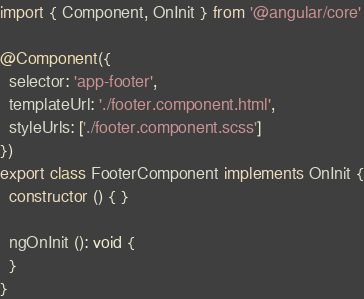Convert code to text. <code><loc_0><loc_0><loc_500><loc_500><_TypeScript_>import { Component, OnInit } from '@angular/core'

@Component({
  selector: 'app-footer',
  templateUrl: './footer.component.html',
  styleUrls: ['./footer.component.scss']
})
export class FooterComponent implements OnInit {
  constructor () { }

  ngOnInit (): void {
  }
}
</code> 